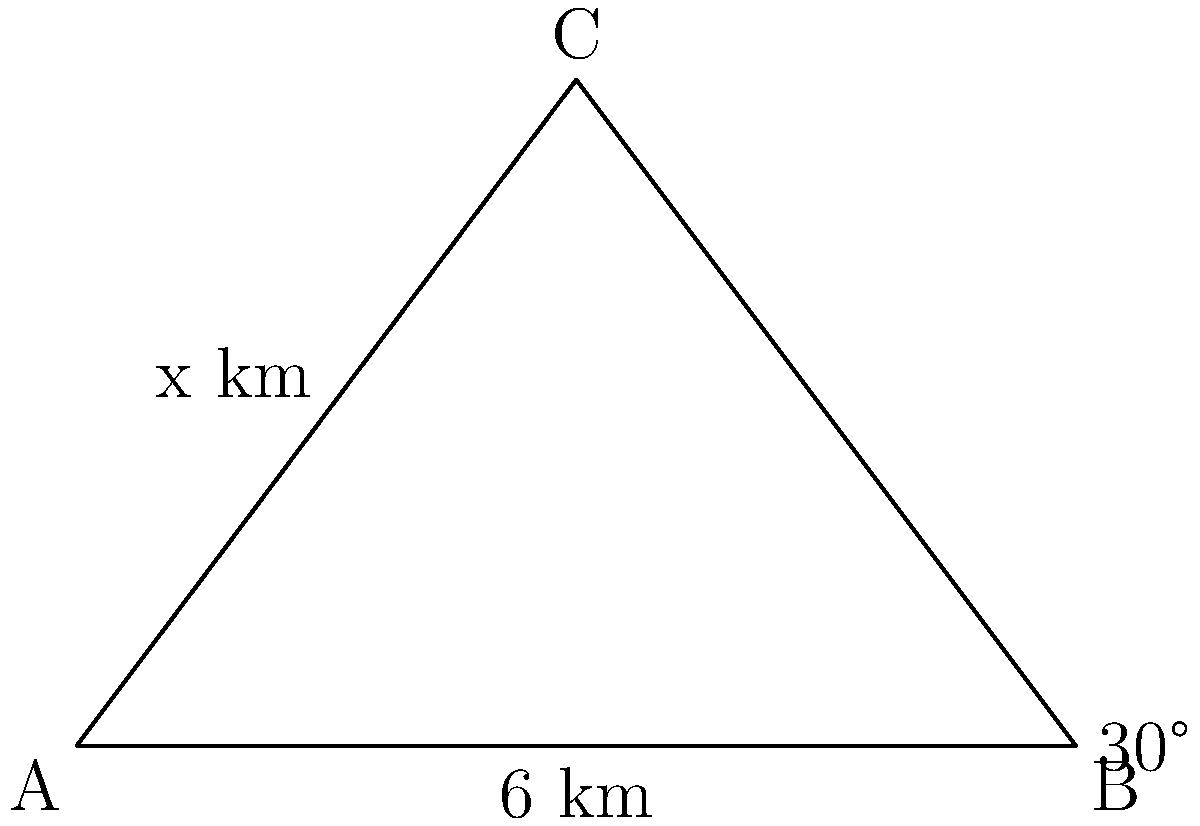A suspect fled from point A to point C, then to point B. The angle at point B is 30°, and the distance from A to B is 6 km. What is the distance from A to C (labeled as x km in the diagram)? To solve this problem, we'll use trigonometry in the right-angled triangle formed by dropping a perpendicular from C to AB. Let's approach this step-by-step:

1) In the triangle ABC, we know:
   - Angle at B is 30°
   - AB = 6 km

2) The triangle ABC is a 30-60-90 triangle. In such a triangle:
   - The side opposite to the 30° angle is half the hypotenuse
   - The side opposite to the 60° angle is $\frac{\sqrt{3}}{2}$ times the hypotenuse

3) AC (which we're trying to find) is the hypotenuse of this triangle.

4) BC (the side opposite to the 60° angle) = $\frac{\sqrt{3}}{2} \cdot 6 = 3\sqrt{3}$ km

5) Now, we can use the Pythagorean theorem in the right-angled triangle:

   $AC^2 = AB^2 + BC^2$

6) Substituting the values:

   $x^2 = 6^2 + (3\sqrt{3})^2$

7) Simplifying:

   $x^2 = 36 + 27 = 63$

8) Taking the square root of both sides:

   $x = \sqrt{63} = 3\sqrt{7}$ km

Therefore, the distance from A to C is $3\sqrt{7}$ km.
Answer: $3\sqrt{7}$ km 